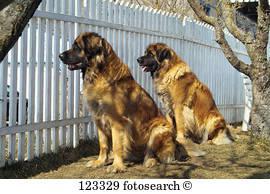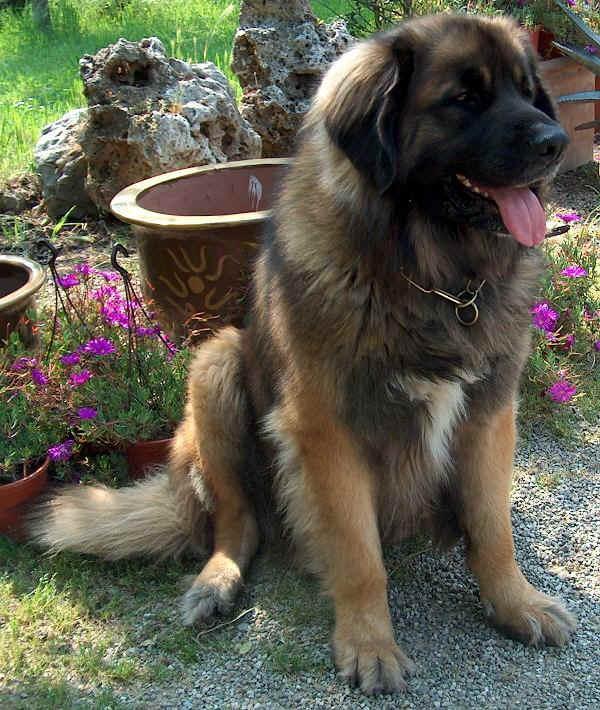The first image is the image on the left, the second image is the image on the right. Assess this claim about the two images: "In one image, two dogs of the same breed are near a fence, while the other image shows a single dog with its mouth open and tongue visible.". Correct or not? Answer yes or no. Yes. The first image is the image on the left, the second image is the image on the right. Given the left and right images, does the statement "Two dogs in similar poses are facing some type of fence in one image." hold true? Answer yes or no. Yes. 